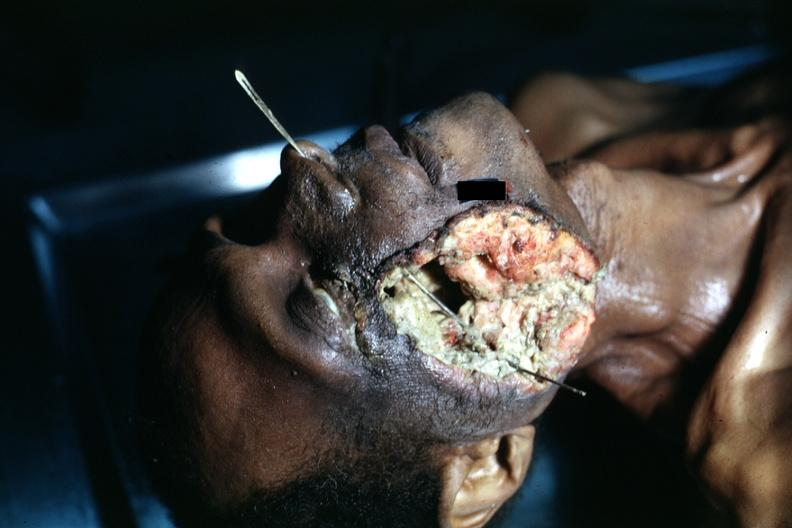s squamous cell carcinoma present?
Answer the question using a single word or phrase. Yes 